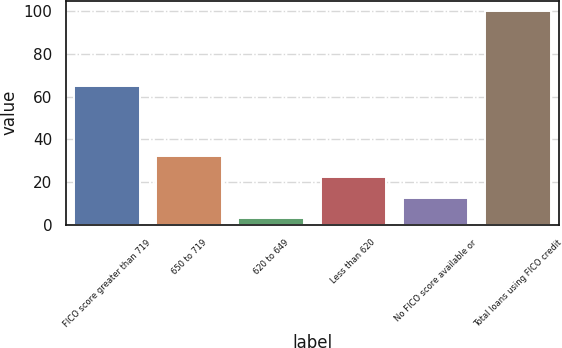Convert chart. <chart><loc_0><loc_0><loc_500><loc_500><bar_chart><fcel>FICO score greater than 719<fcel>650 to 719<fcel>620 to 649<fcel>Less than 620<fcel>No FICO score available or<fcel>Total loans using FICO credit<nl><fcel>65<fcel>32.1<fcel>3<fcel>22.4<fcel>12.7<fcel>100<nl></chart> 